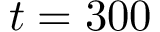<formula> <loc_0><loc_0><loc_500><loc_500>t = 3 0 0</formula> 